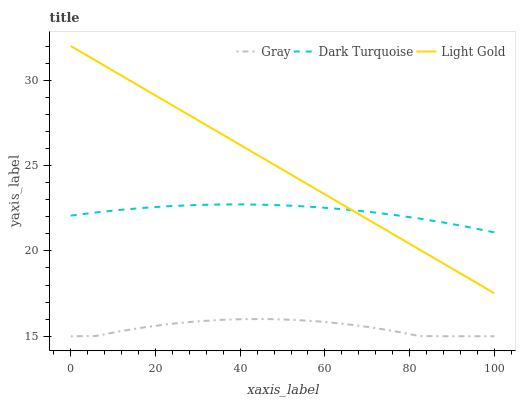Does Gray have the minimum area under the curve?
Answer yes or no. Yes. Does Light Gold have the maximum area under the curve?
Answer yes or no. Yes. Does Dark Turquoise have the minimum area under the curve?
Answer yes or no. No. Does Dark Turquoise have the maximum area under the curve?
Answer yes or no. No. Is Light Gold the smoothest?
Answer yes or no. Yes. Is Gray the roughest?
Answer yes or no. Yes. Is Dark Turquoise the smoothest?
Answer yes or no. No. Is Dark Turquoise the roughest?
Answer yes or no. No. Does Gray have the lowest value?
Answer yes or no. Yes. Does Light Gold have the lowest value?
Answer yes or no. No. Does Light Gold have the highest value?
Answer yes or no. Yes. Does Dark Turquoise have the highest value?
Answer yes or no. No. Is Gray less than Dark Turquoise?
Answer yes or no. Yes. Is Light Gold greater than Gray?
Answer yes or no. Yes. Does Light Gold intersect Dark Turquoise?
Answer yes or no. Yes. Is Light Gold less than Dark Turquoise?
Answer yes or no. No. Is Light Gold greater than Dark Turquoise?
Answer yes or no. No. Does Gray intersect Dark Turquoise?
Answer yes or no. No. 